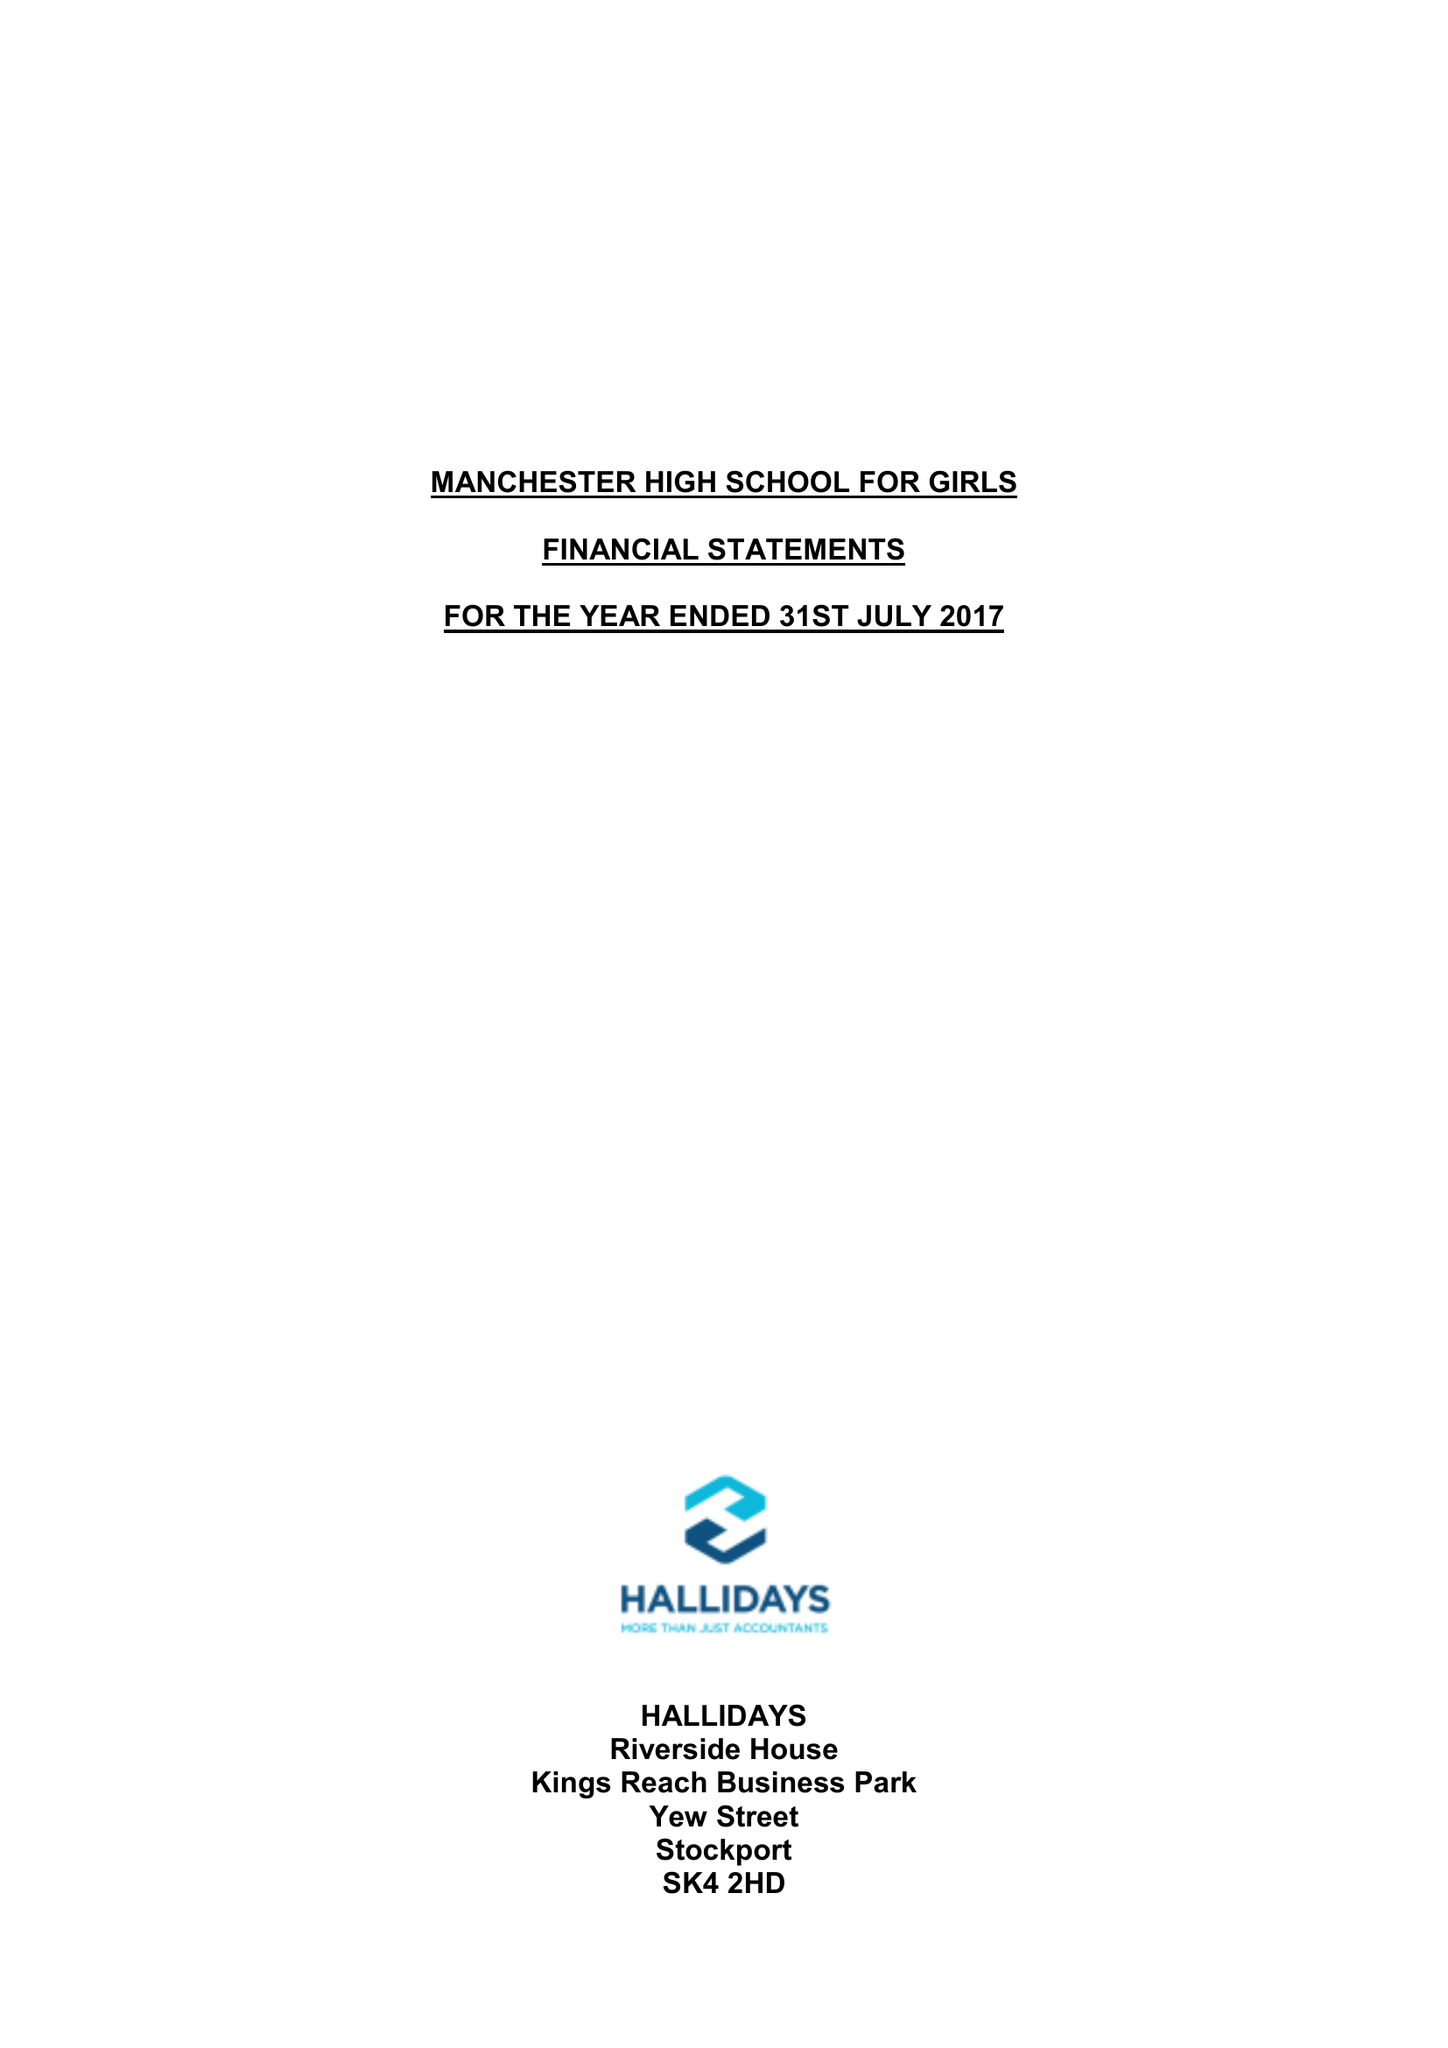What is the value for the address__post_town?
Answer the question using a single word or phrase. MANCHESTER 